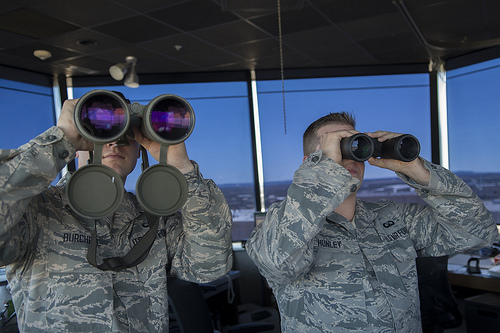<image>
Is there a john behind the paul? Yes. From this viewpoint, the john is positioned behind the paul, with the paul partially or fully occluding the john. 